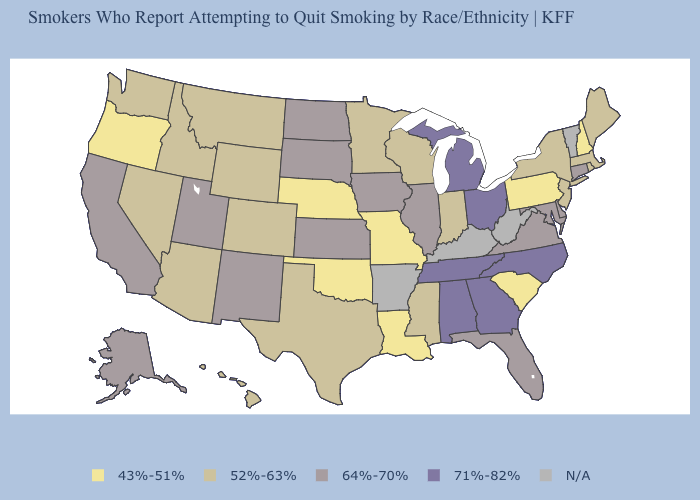What is the value of Oregon?
Short answer required. 43%-51%. How many symbols are there in the legend?
Keep it brief. 5. Name the states that have a value in the range 52%-63%?
Be succinct. Arizona, Colorado, Hawaii, Idaho, Indiana, Maine, Massachusetts, Minnesota, Mississippi, Montana, Nevada, New Jersey, New York, Rhode Island, Texas, Washington, Wisconsin, Wyoming. Does the map have missing data?
Give a very brief answer. Yes. Name the states that have a value in the range 43%-51%?
Write a very short answer. Louisiana, Missouri, Nebraska, New Hampshire, Oklahoma, Oregon, Pennsylvania, South Carolina. Among the states that border South Dakota , which have the lowest value?
Answer briefly. Nebraska. Which states have the highest value in the USA?
Be succinct. Alabama, Georgia, Michigan, North Carolina, Ohio, Tennessee. What is the value of Michigan?
Be succinct. 71%-82%. Name the states that have a value in the range 43%-51%?
Concise answer only. Louisiana, Missouri, Nebraska, New Hampshire, Oklahoma, Oregon, Pennsylvania, South Carolina. What is the value of North Dakota?
Answer briefly. 64%-70%. Does the first symbol in the legend represent the smallest category?
Answer briefly. Yes. Name the states that have a value in the range 43%-51%?
Answer briefly. Louisiana, Missouri, Nebraska, New Hampshire, Oklahoma, Oregon, Pennsylvania, South Carolina. What is the value of Oregon?
Write a very short answer. 43%-51%. What is the lowest value in the South?
Keep it brief. 43%-51%. 